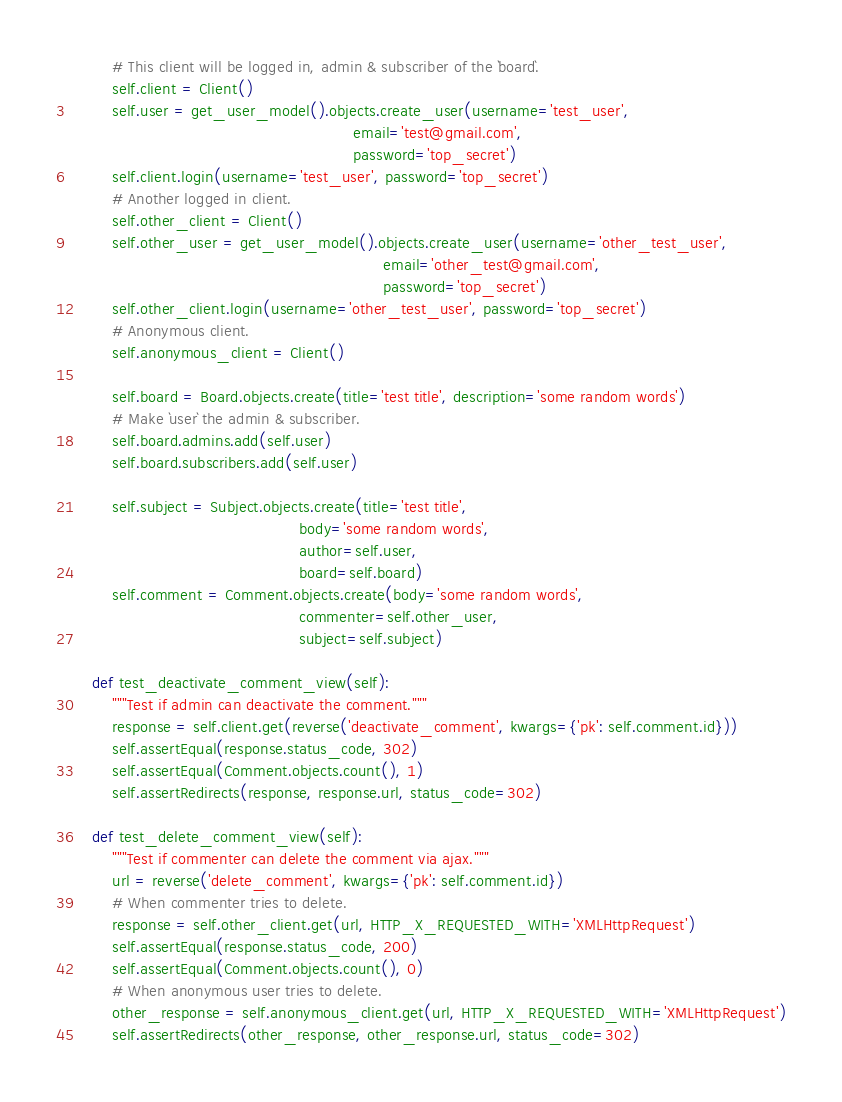Convert code to text. <code><loc_0><loc_0><loc_500><loc_500><_Python_>        # This client will be logged in, admin & subscriber of the `board`.
        self.client = Client()
        self.user = get_user_model().objects.create_user(username='test_user',
                                                         email='test@gmail.com',
                                                         password='top_secret')
        self.client.login(username='test_user', password='top_secret')
        # Another logged in client.
        self.other_client = Client()
        self.other_user = get_user_model().objects.create_user(username='other_test_user',
                                                               email='other_test@gmail.com',
                                                               password='top_secret')
        self.other_client.login(username='other_test_user', password='top_secret')
        # Anonymous client.
        self.anonymous_client = Client()

        self.board = Board.objects.create(title='test title', description='some random words')
        # Make `user` the admin & subscriber.
        self.board.admins.add(self.user)
        self.board.subscribers.add(self.user)

        self.subject = Subject.objects.create(title='test title',
                                              body='some random words',
                                              author=self.user,
                                              board=self.board)
        self.comment = Comment.objects.create(body='some random words',
                                              commenter=self.other_user,
                                              subject=self.subject)

    def test_deactivate_comment_view(self):
        """Test if admin can deactivate the comment."""
        response = self.client.get(reverse('deactivate_comment', kwargs={'pk': self.comment.id}))
        self.assertEqual(response.status_code, 302)
        self.assertEqual(Comment.objects.count(), 1)
        self.assertRedirects(response, response.url, status_code=302)

    def test_delete_comment_view(self):
        """Test if commenter can delete the comment via ajax."""
        url = reverse('delete_comment', kwargs={'pk': self.comment.id})
        # When commenter tries to delete.
        response = self.other_client.get(url, HTTP_X_REQUESTED_WITH='XMLHttpRequest')
        self.assertEqual(response.status_code, 200)
        self.assertEqual(Comment.objects.count(), 0)
        # When anonymous user tries to delete.
        other_response = self.anonymous_client.get(url, HTTP_X_REQUESTED_WITH='XMLHttpRequest')
        self.assertRedirects(other_response, other_response.url, status_code=302)
</code> 